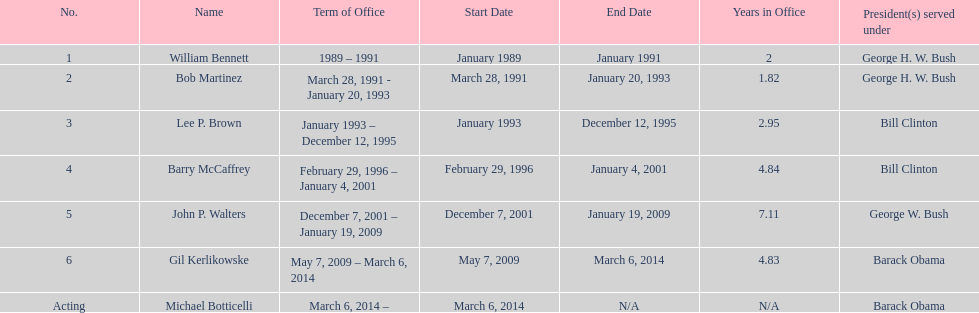What were the total number of years bob martinez served in office? 2. 